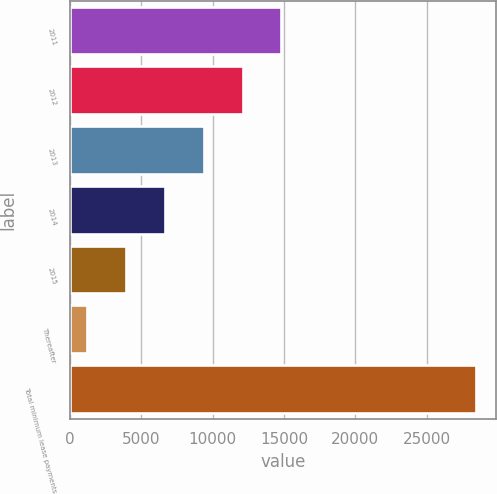Convert chart. <chart><loc_0><loc_0><loc_500><loc_500><bar_chart><fcel>2011<fcel>2012<fcel>2013<fcel>2014<fcel>2015<fcel>Thereafter<fcel>Total minimum lease payments<nl><fcel>14823.5<fcel>12097.8<fcel>9372.1<fcel>6646.4<fcel>3920.7<fcel>1195<fcel>28452<nl></chart> 